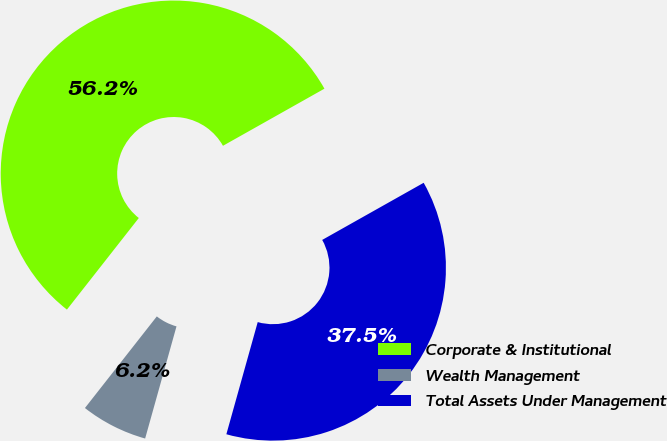<chart> <loc_0><loc_0><loc_500><loc_500><pie_chart><fcel>Corporate & Institutional<fcel>Wealth Management<fcel>Total Assets Under Management<nl><fcel>56.25%<fcel>6.25%<fcel>37.5%<nl></chart> 